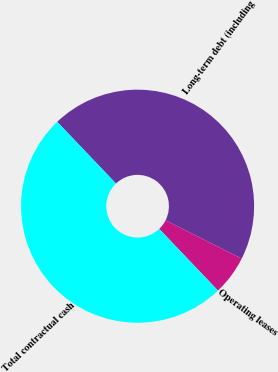Convert chart to OTSL. <chart><loc_0><loc_0><loc_500><loc_500><pie_chart><fcel>Long-term debt (including<fcel>Operating leases<fcel>Total contractual cash<nl><fcel>44.54%<fcel>5.46%<fcel>50.0%<nl></chart> 